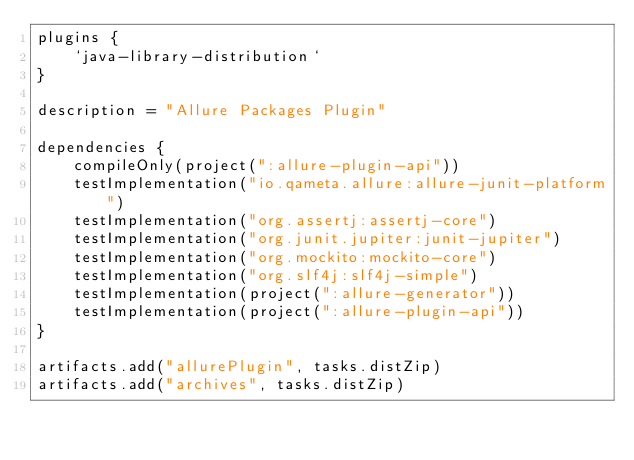<code> <loc_0><loc_0><loc_500><loc_500><_Kotlin_>plugins {
    `java-library-distribution`
}

description = "Allure Packages Plugin"

dependencies {
    compileOnly(project(":allure-plugin-api"))
    testImplementation("io.qameta.allure:allure-junit-platform")
    testImplementation("org.assertj:assertj-core")
    testImplementation("org.junit.jupiter:junit-jupiter")
    testImplementation("org.mockito:mockito-core")
    testImplementation("org.slf4j:slf4j-simple")
    testImplementation(project(":allure-generator"))
    testImplementation(project(":allure-plugin-api"))
}

artifacts.add("allurePlugin", tasks.distZip)
artifacts.add("archives", tasks.distZip)
</code> 